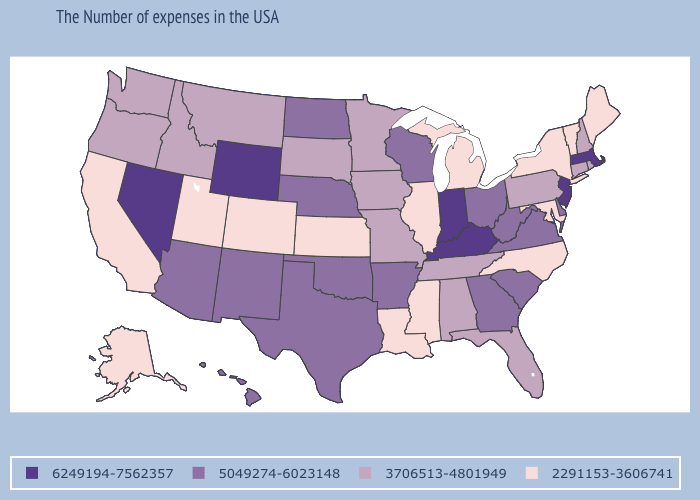Name the states that have a value in the range 3706513-4801949?
Be succinct. Rhode Island, New Hampshire, Connecticut, Pennsylvania, Florida, Alabama, Tennessee, Missouri, Minnesota, Iowa, South Dakota, Montana, Idaho, Washington, Oregon. Among the states that border Wyoming , does Colorado have the lowest value?
Keep it brief. Yes. What is the value of South Carolina?
Concise answer only. 5049274-6023148. What is the highest value in the MidWest ?
Answer briefly. 6249194-7562357. Name the states that have a value in the range 3706513-4801949?
Give a very brief answer. Rhode Island, New Hampshire, Connecticut, Pennsylvania, Florida, Alabama, Tennessee, Missouri, Minnesota, Iowa, South Dakota, Montana, Idaho, Washington, Oregon. Which states have the lowest value in the USA?
Be succinct. Maine, Vermont, New York, Maryland, North Carolina, Michigan, Illinois, Mississippi, Louisiana, Kansas, Colorado, Utah, California, Alaska. Does Idaho have a lower value than Tennessee?
Answer briefly. No. Does the map have missing data?
Write a very short answer. No. What is the value of New Jersey?
Give a very brief answer. 6249194-7562357. Among the states that border New Jersey , does Pennsylvania have the highest value?
Answer briefly. No. What is the value of Alaska?
Give a very brief answer. 2291153-3606741. What is the value of South Carolina?
Write a very short answer. 5049274-6023148. Does New Jersey have the highest value in the USA?
Be succinct. Yes. What is the value of Mississippi?
Keep it brief. 2291153-3606741. Does Ohio have the highest value in the USA?
Answer briefly. No. 